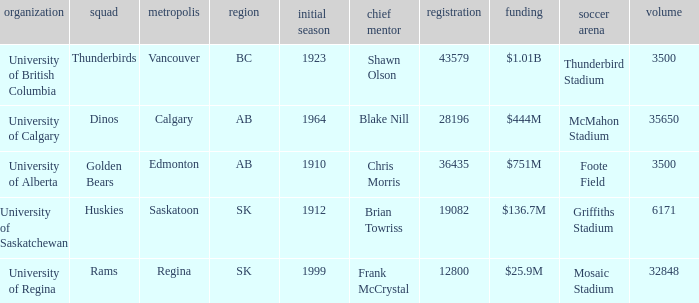What year did University of Saskatchewan have their first season? 1912.0. 